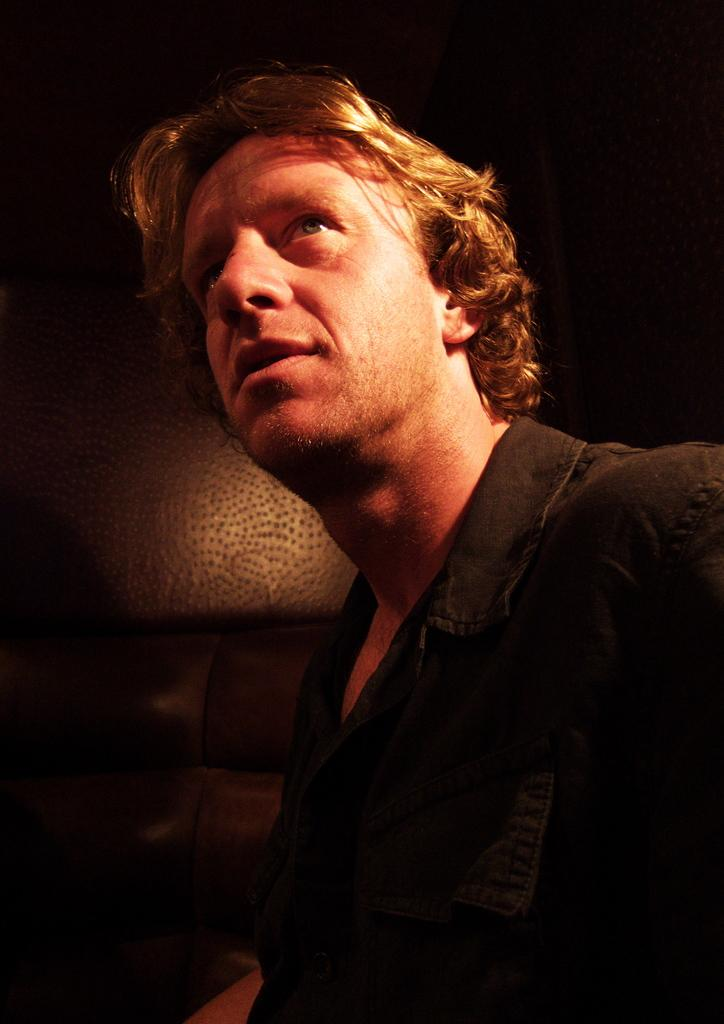Who is present in the image? There is a man in the image. What can be seen on the man's face? There is a light on the man's face. What color is the shirt the man is wearing? The man is wearing a black color shirt. What type of brain is visible in the image? There is no brain visible in the image; it features a man with a light on his face and wearing a black shirt. 